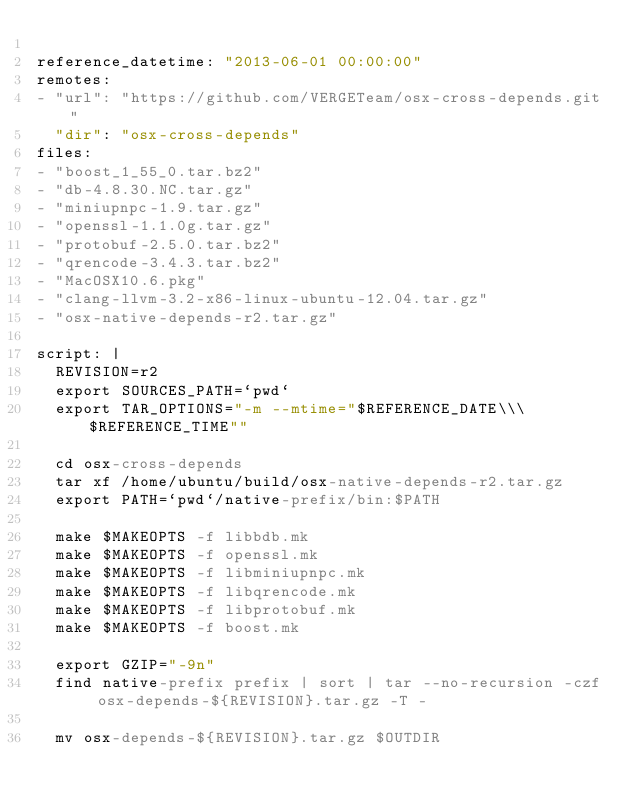<code> <loc_0><loc_0><loc_500><loc_500><_YAML_>
reference_datetime: "2013-06-01 00:00:00"
remotes:
- "url": "https://github.com/VERGETeam/osx-cross-depends.git"
  "dir": "osx-cross-depends"
files:
- "boost_1_55_0.tar.bz2"
- "db-4.8.30.NC.tar.gz"
- "miniupnpc-1.9.tar.gz"
- "openssl-1.1.0g.tar.gz"
- "protobuf-2.5.0.tar.bz2"
- "qrencode-3.4.3.tar.bz2"
- "MacOSX10.6.pkg"
- "clang-llvm-3.2-x86-linux-ubuntu-12.04.tar.gz"
- "osx-native-depends-r2.tar.gz"

script: |
  REVISION=r2
  export SOURCES_PATH=`pwd`
  export TAR_OPTIONS="-m --mtime="$REFERENCE_DATE\\\ $REFERENCE_TIME""

  cd osx-cross-depends
  tar xf /home/ubuntu/build/osx-native-depends-r2.tar.gz
  export PATH=`pwd`/native-prefix/bin:$PATH

  make $MAKEOPTS -f libbdb.mk
  make $MAKEOPTS -f openssl.mk
  make $MAKEOPTS -f libminiupnpc.mk
  make $MAKEOPTS -f libqrencode.mk
  make $MAKEOPTS -f libprotobuf.mk
  make $MAKEOPTS -f boost.mk

  export GZIP="-9n"
  find native-prefix prefix | sort | tar --no-recursion -czf osx-depends-${REVISION}.tar.gz -T -

  mv osx-depends-${REVISION}.tar.gz $OUTDIR
</code> 